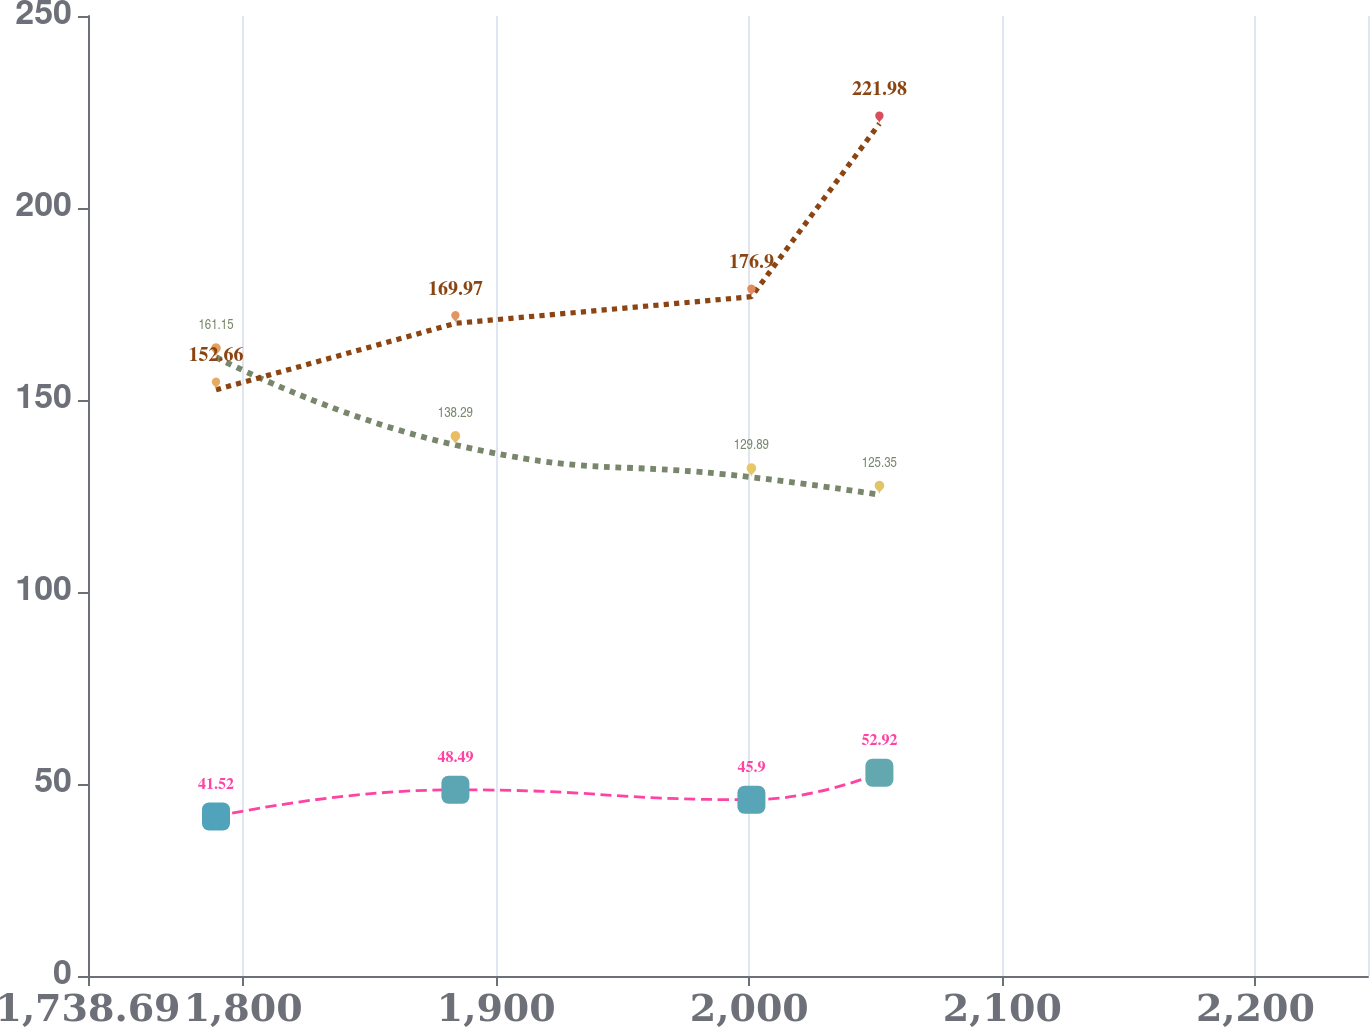Convert chart. <chart><loc_0><loc_0><loc_500><loc_500><line_chart><ecel><fcel>US<fcel>International<fcel>Medical Plan<nl><fcel>1789.27<fcel>161.15<fcel>152.66<fcel>41.52<nl><fcel>1883.87<fcel>138.29<fcel>169.97<fcel>48.49<nl><fcel>2000.84<fcel>129.89<fcel>176.9<fcel>45.9<nl><fcel>2051.42<fcel>125.35<fcel>221.98<fcel>52.92<nl><fcel>2295.07<fcel>170.74<fcel>184.78<fcel>63.31<nl></chart> 